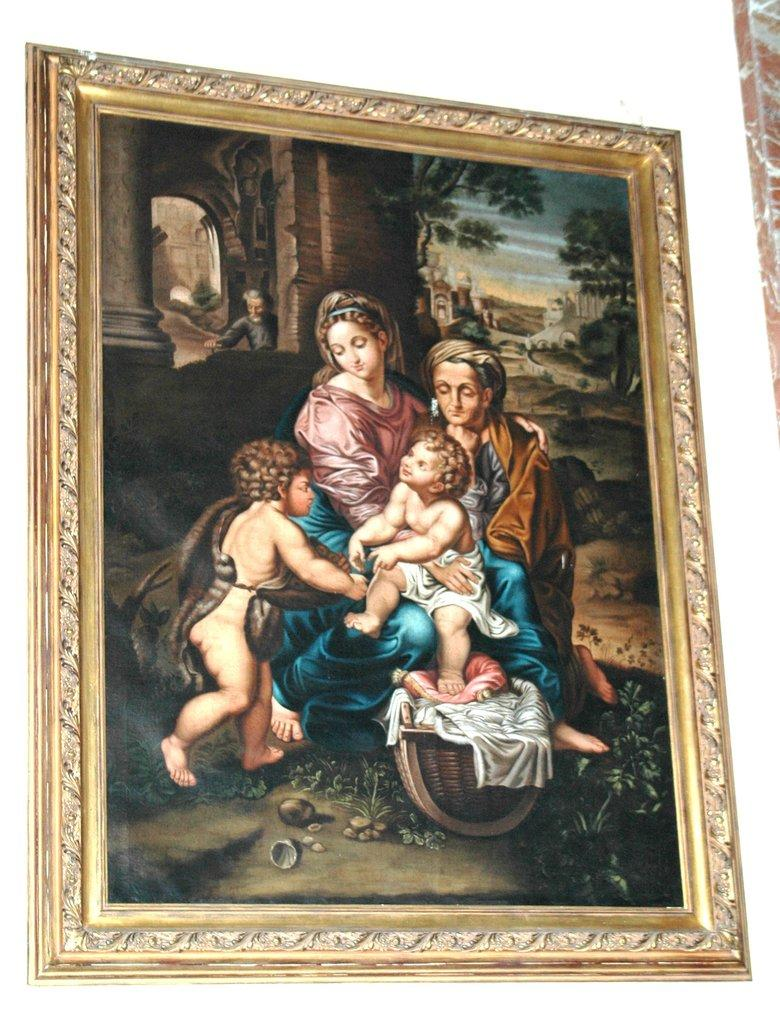How many people are in the front of the image? There are two persons and two children in the front of the image. What can be seen in the background of the image? There are buildings and trees in the background of the image. Are there any other people visible in the image? Yes, there is one more person in the background of the image. What type of grape is being used as a pillow for the children in the image? There are no grapes present in the image, and the children are not using any grapes as pillows. How many beds are visible in the image? There are no beds visible in the image. 